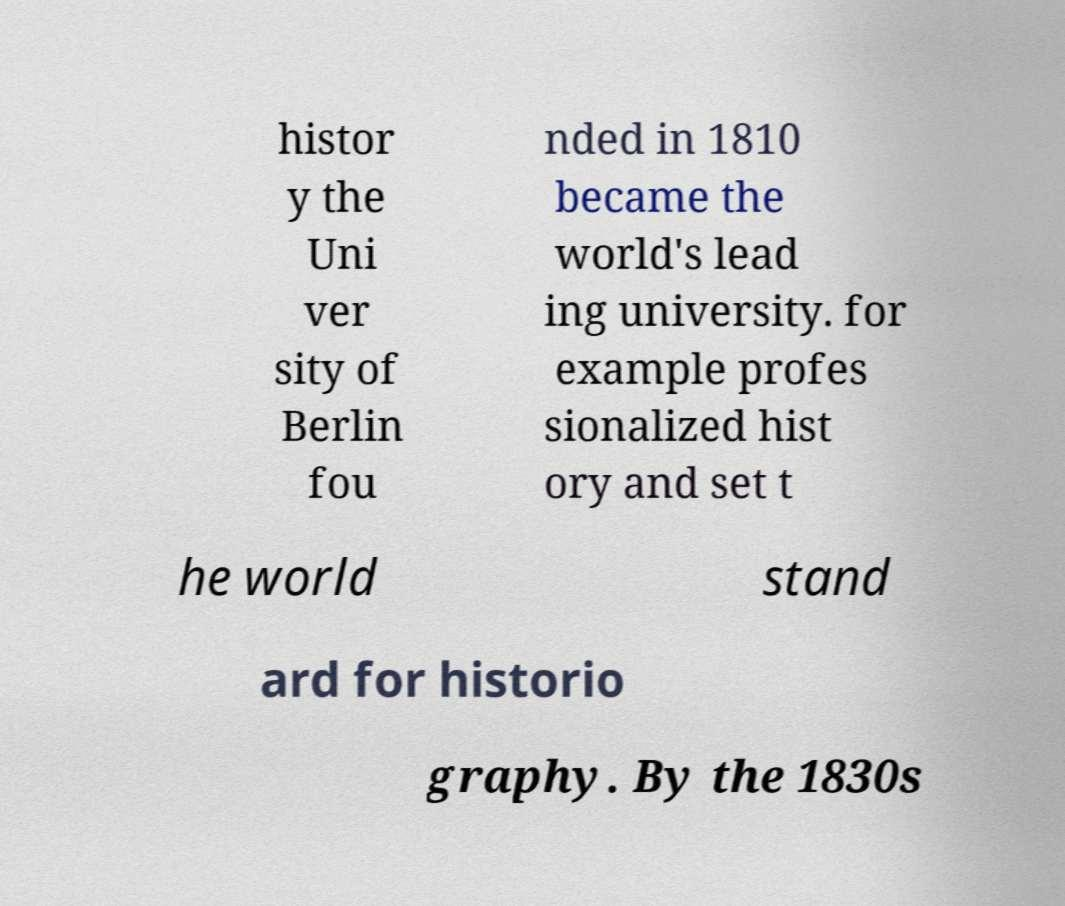Please identify and transcribe the text found in this image. histor y the Uni ver sity of Berlin fou nded in 1810 became the world's lead ing university. for example profes sionalized hist ory and set t he world stand ard for historio graphy. By the 1830s 